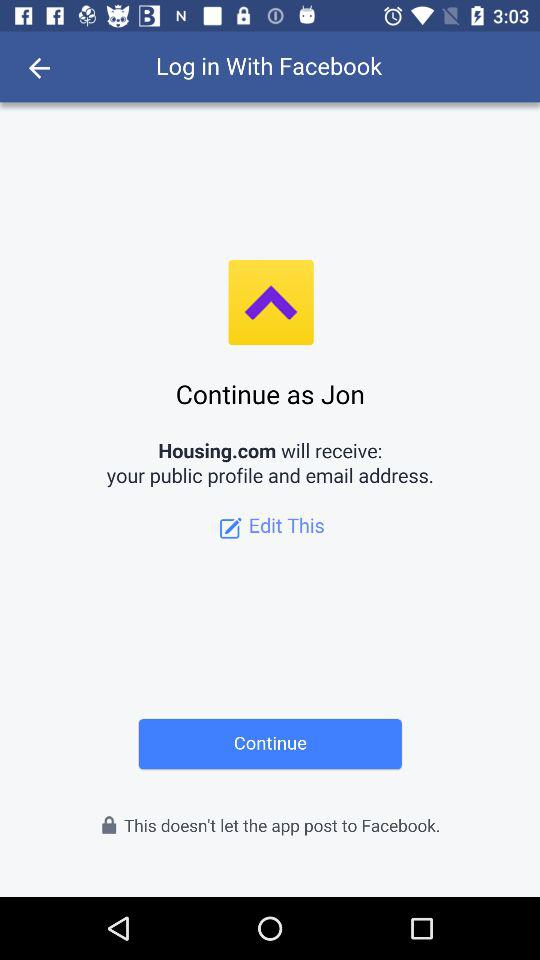Who will receive the public figure and email address? The public figure and email address will be received by Housing.com. 